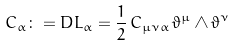Convert formula to latex. <formula><loc_0><loc_0><loc_500><loc_500>C _ { \alpha } \colon = D L _ { \alpha } = \frac { 1 } { 2 } \, C _ { \mu \nu \alpha } \, \vartheta ^ { \mu } \wedge \vartheta ^ { \nu }</formula> 